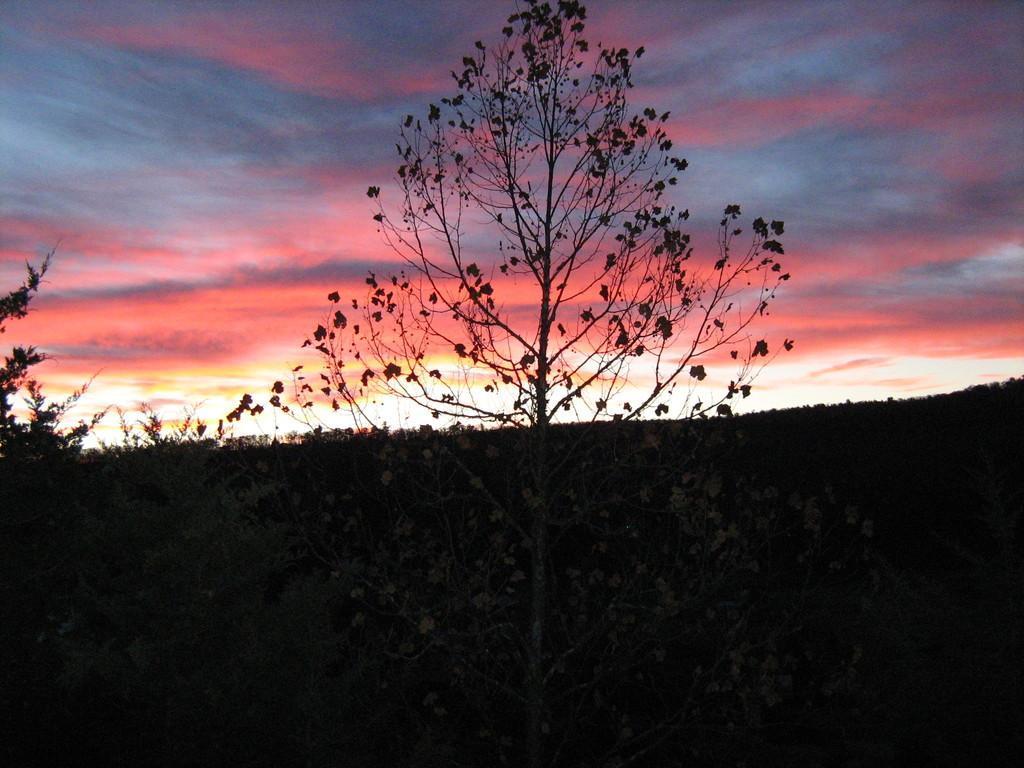In one or two sentences, can you explain what this image depicts? In this picture there is a tree in the center of the image and there is greenery at the bottom side of the image and there is sky at the top side of the image. 